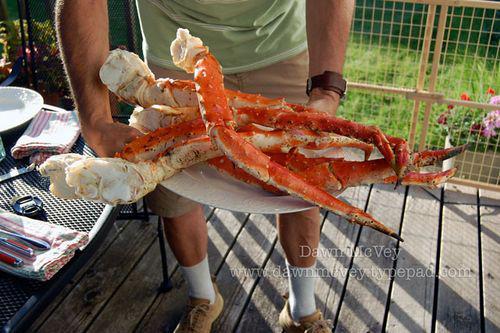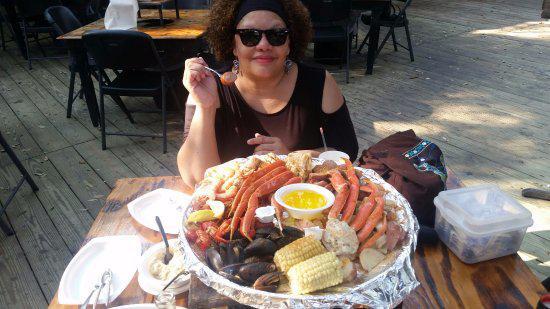The first image is the image on the left, the second image is the image on the right. For the images shown, is this caption "A single person who is a woman is sitting behind a platter of seafood in one of the images." true? Answer yes or no. Yes. 